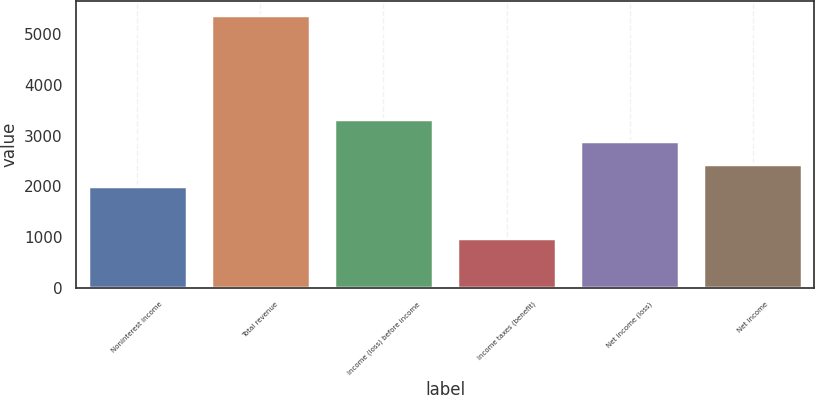Convert chart. <chart><loc_0><loc_0><loc_500><loc_500><bar_chart><fcel>Noninterest income<fcel>Total revenue<fcel>Income (loss) before income<fcel>Income taxes (benefit)<fcel>Net income (loss)<fcel>Net income<nl><fcel>2006<fcel>5379<fcel>3325.1<fcel>982<fcel>2885.4<fcel>2445.7<nl></chart> 